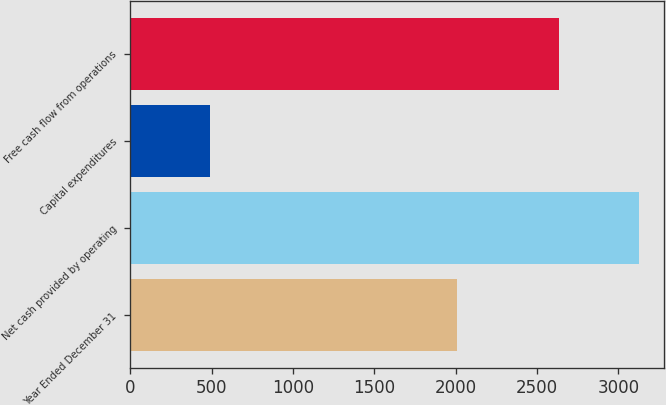Convert chart to OTSL. <chart><loc_0><loc_0><loc_500><loc_500><bar_chart><fcel>Year Ended December 31<fcel>Net cash provided by operating<fcel>Capital expenditures<fcel>Free cash flow from operations<nl><fcel>2008<fcel>3124<fcel>490<fcel>2634<nl></chart> 